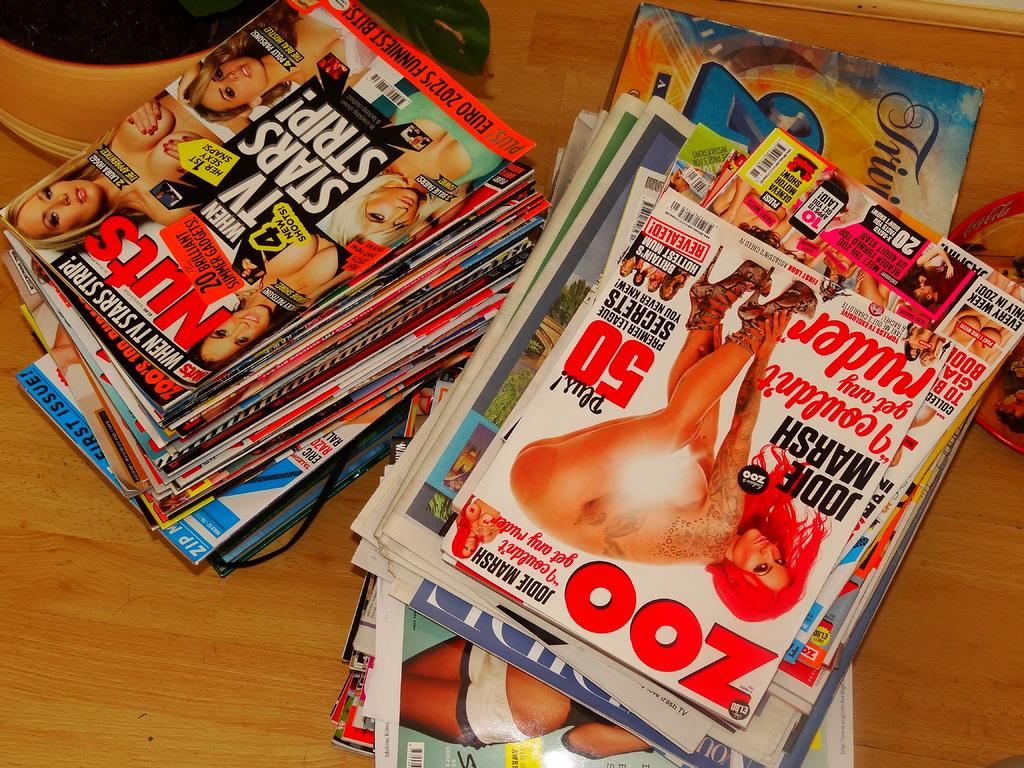<image>
Render a clear and concise summary of the photo. A stack of adult magazines showing a woman bent over named Jodie Marsh. 